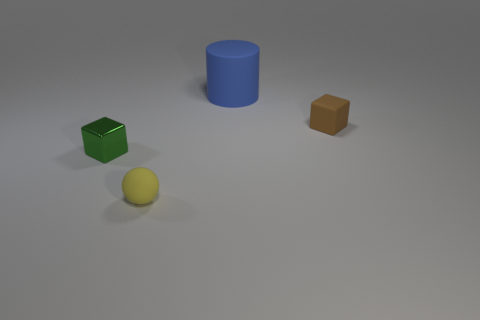What number of things are small blocks that are to the left of the rubber block or tiny matte things that are on the left side of the tiny brown rubber cube?
Offer a very short reply. 2. Are there an equal number of green objects and tiny green metal cylinders?
Your answer should be very brief. No. How many objects are either spheres or large yellow metal objects?
Your response must be concise. 1. There is a big blue rubber cylinder on the left side of the brown rubber object; how many things are behind it?
Keep it short and to the point. 0. What number of other things are the same size as the matte sphere?
Your response must be concise. 2. Does the matte thing that is on the right side of the large cylinder have the same shape as the blue rubber thing?
Ensure brevity in your answer.  No. What is the tiny thing on the right side of the cylinder made of?
Make the answer very short. Rubber. Are there any red cubes made of the same material as the blue object?
Give a very brief answer. No. How big is the brown matte block?
Your answer should be compact. Small. What number of brown objects are either matte blocks or big things?
Provide a succinct answer. 1. 